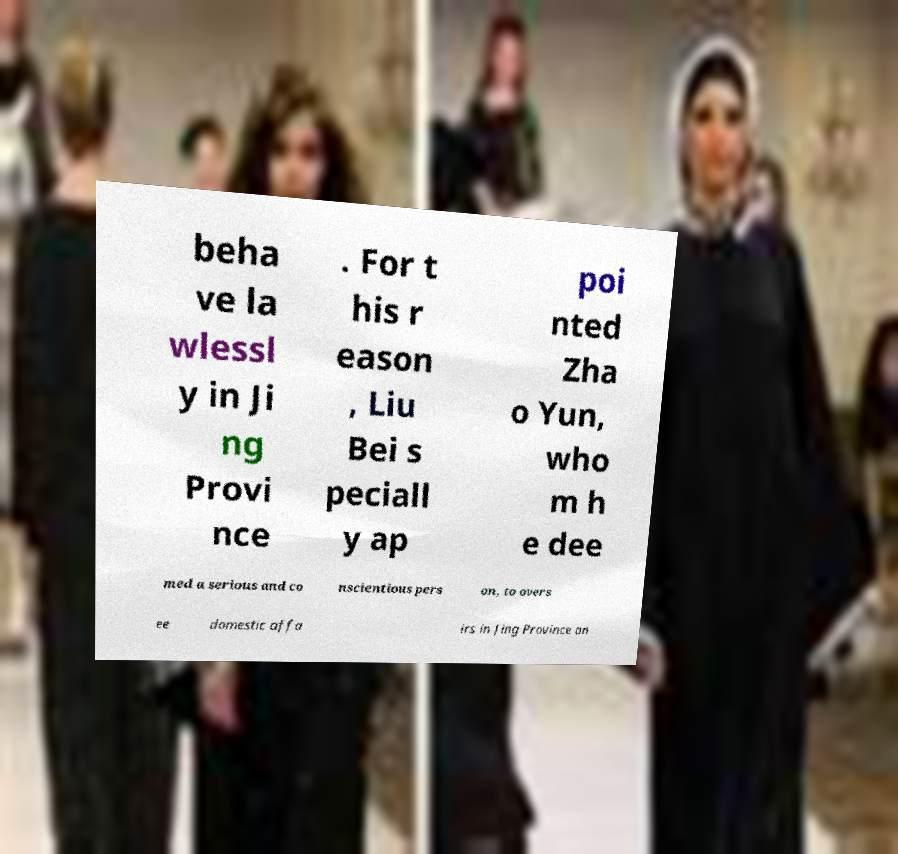Can you read and provide the text displayed in the image?This photo seems to have some interesting text. Can you extract and type it out for me? beha ve la wlessl y in Ji ng Provi nce . For t his r eason , Liu Bei s peciall y ap poi nted Zha o Yun, who m h e dee med a serious and co nscientious pers on, to overs ee domestic affa irs in Jing Province an 